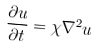<formula> <loc_0><loc_0><loc_500><loc_500>\frac { \partial u } { \partial t } = \chi \nabla ^ { 2 } u</formula> 